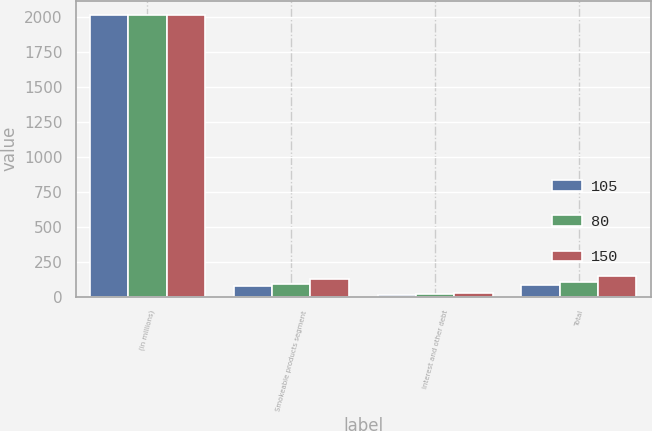Convert chart to OTSL. <chart><loc_0><loc_0><loc_500><loc_500><stacked_bar_chart><ecel><fcel>(in millions)<fcel>Smokeable products segment<fcel>Interest and other debt<fcel>Total<nl><fcel>105<fcel>2017<fcel>72<fcel>8<fcel>80<nl><fcel>80<fcel>2016<fcel>88<fcel>17<fcel>105<nl><fcel>150<fcel>2015<fcel>127<fcel>23<fcel>150<nl></chart> 